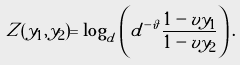Convert formula to latex. <formula><loc_0><loc_0><loc_500><loc_500>Z ( y _ { 1 } , y _ { 2 } ) = \log _ { d } \left ( d ^ { - \vartheta } \frac { 1 - v y _ { 1 } } { 1 - v y _ { 2 } } \right ) .</formula> 